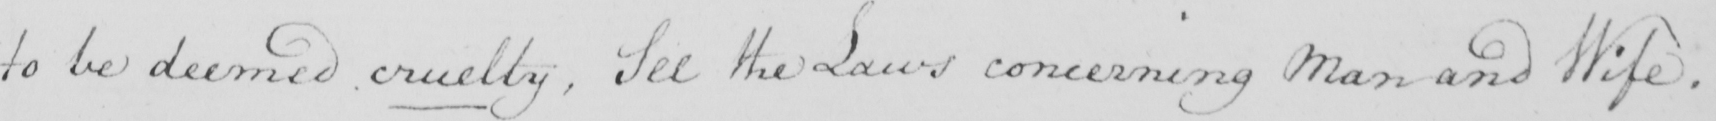What text is written in this handwritten line? to be deemed cruelty , See the Laws concerning Man and Wife . 